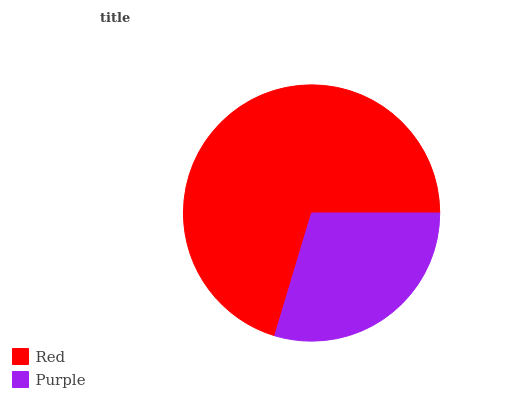Is Purple the minimum?
Answer yes or no. Yes. Is Red the maximum?
Answer yes or no. Yes. Is Purple the maximum?
Answer yes or no. No. Is Red greater than Purple?
Answer yes or no. Yes. Is Purple less than Red?
Answer yes or no. Yes. Is Purple greater than Red?
Answer yes or no. No. Is Red less than Purple?
Answer yes or no. No. Is Red the high median?
Answer yes or no. Yes. Is Purple the low median?
Answer yes or no. Yes. Is Purple the high median?
Answer yes or no. No. Is Red the low median?
Answer yes or no. No. 